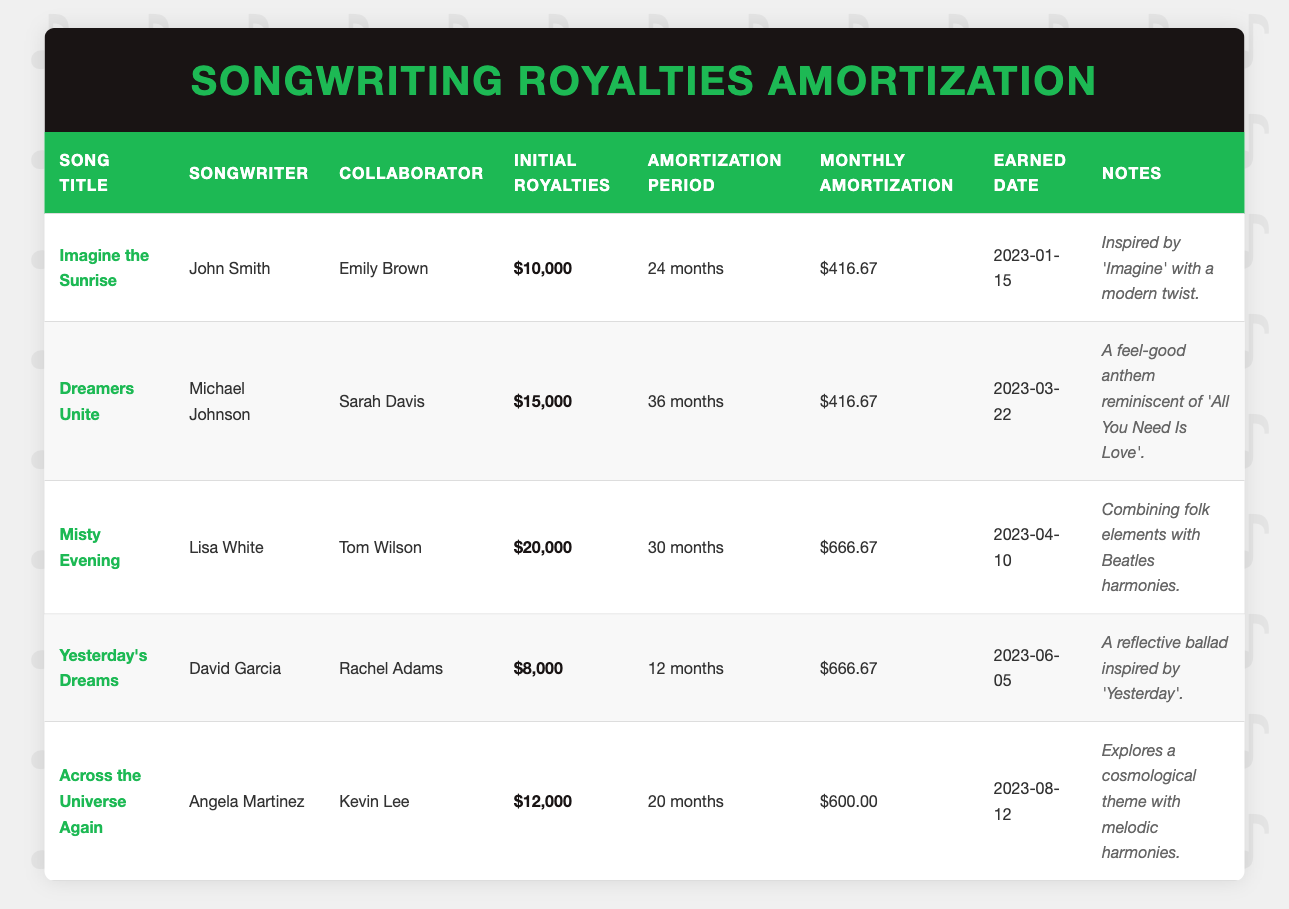What is the initial royalties for "Dreamers Unite"? The initial royalties for "Dreamers Unite" can be found in the table under the "Initial Royalties" column for that song. It states $15,000.
Answer: $15,000 How many months is the amortization period for "Across the Universe Again"? The amortization period for "Across the Universe Again" is indicated in the "Amortization Period" column in the table. It shows 20 months.
Answer: 20 months What is the total initial royalties earned from all songs listed? To find the total initial royalties, sum the values in the "Initial Royalties" column for each song: (10000 + 15000 + 20000 + 8000 + 12000) = 65000.
Answer: $65,000 Is "Misty Evening" attributed to Lisa White? By checking the "Songwriter" column for "Misty Evening", it confirms that the songwriter is indeed Lisa White.
Answer: Yes Which songwriter has the highest initial royalties? The songwriter with the highest initial royalties can be identified by comparing the values in the "Initial Royalties" column. "Misty Evening" has $20,000, which is the highest amount.
Answer: Lisa White What is the average monthly amortization across all songs? To find the average monthly amortization, sum the values in the "Monthly Amortization" column: (416.67 + 416.67 + 666.67 + 666.67 + 600) = 2786.68. Then divide by the number of songs (5): 2786.68 / 5 = 557.34.
Answer: $557.34 How many collaborators were involved in the song "Yesterday's Dreams"? The table shows one collaborator listed for "Yesterday's Dreams" in the "Collaborator" column, which is Rachel Adams.
Answer: 1 Are there any songs with an amortization period of more than 24 months? By checking the "Amortization Period" column for each song, it shows that both "Dreamers Unite" and "Misty Evening" have amortization periods of 36 months and 30 months, respectively, confirming that there are songs with more than 24 months.
Answer: Yes Which song has the lowest initial royalties and what is the amount? Looking at the "Initial Royalties" column, "Yesterday's Dreams" has the lowest initial royalties of $8,000.
Answer: "Yesterday's Dreams", $8,000 